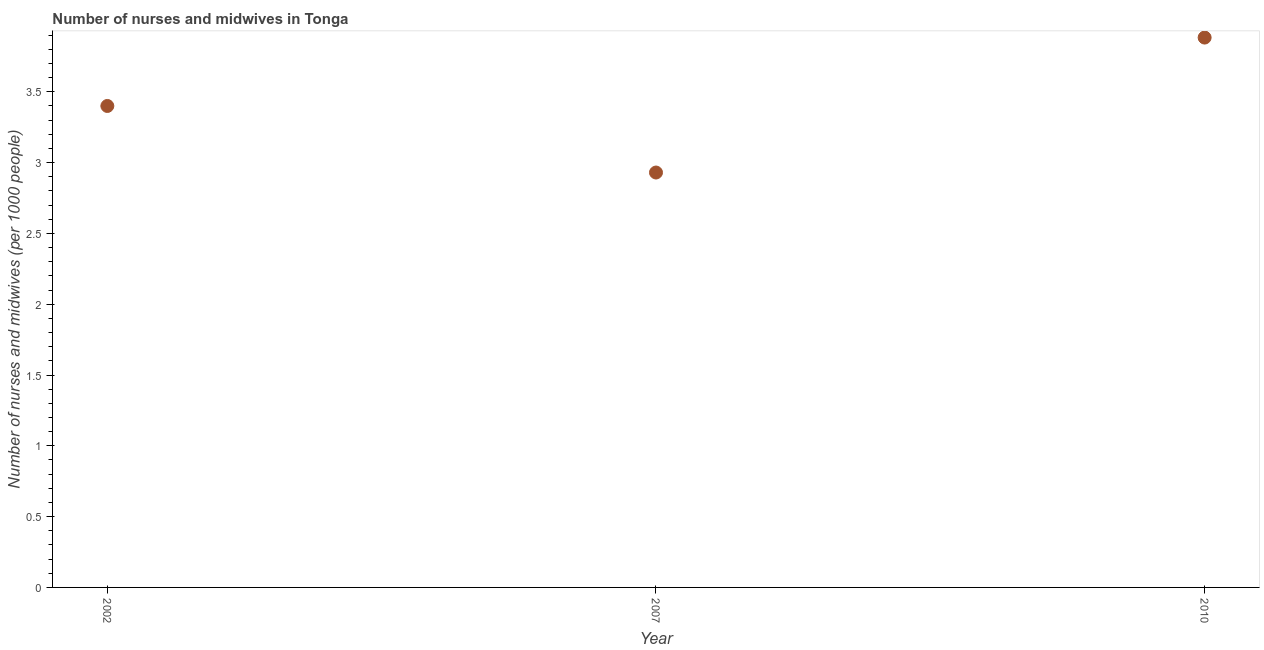What is the number of nurses and midwives in 2007?
Provide a succinct answer. 2.93. Across all years, what is the maximum number of nurses and midwives?
Offer a very short reply. 3.88. Across all years, what is the minimum number of nurses and midwives?
Provide a succinct answer. 2.93. In which year was the number of nurses and midwives minimum?
Give a very brief answer. 2007. What is the sum of the number of nurses and midwives?
Offer a terse response. 10.21. What is the difference between the number of nurses and midwives in 2002 and 2007?
Offer a terse response. 0.47. What is the average number of nurses and midwives per year?
Offer a very short reply. 3.4. In how many years, is the number of nurses and midwives greater than 1 ?
Your answer should be compact. 3. Do a majority of the years between 2002 and 2010 (inclusive) have number of nurses and midwives greater than 3.4 ?
Give a very brief answer. No. What is the ratio of the number of nurses and midwives in 2002 to that in 2007?
Give a very brief answer. 1.16. Is the difference between the number of nurses and midwives in 2007 and 2010 greater than the difference between any two years?
Offer a terse response. Yes. What is the difference between the highest and the second highest number of nurses and midwives?
Keep it short and to the point. 0.48. Is the sum of the number of nurses and midwives in 2002 and 2007 greater than the maximum number of nurses and midwives across all years?
Make the answer very short. Yes. What is the difference between the highest and the lowest number of nurses and midwives?
Offer a terse response. 0.95. Does the number of nurses and midwives monotonically increase over the years?
Give a very brief answer. No. How many years are there in the graph?
Offer a terse response. 3. What is the difference between two consecutive major ticks on the Y-axis?
Provide a succinct answer. 0.5. What is the title of the graph?
Make the answer very short. Number of nurses and midwives in Tonga. What is the label or title of the Y-axis?
Your answer should be compact. Number of nurses and midwives (per 1000 people). What is the Number of nurses and midwives (per 1000 people) in 2002?
Offer a very short reply. 3.4. What is the Number of nurses and midwives (per 1000 people) in 2007?
Keep it short and to the point. 2.93. What is the Number of nurses and midwives (per 1000 people) in 2010?
Offer a terse response. 3.88. What is the difference between the Number of nurses and midwives (per 1000 people) in 2002 and 2007?
Provide a short and direct response. 0.47. What is the difference between the Number of nurses and midwives (per 1000 people) in 2002 and 2010?
Ensure brevity in your answer.  -0.48. What is the difference between the Number of nurses and midwives (per 1000 people) in 2007 and 2010?
Your response must be concise. -0.95. What is the ratio of the Number of nurses and midwives (per 1000 people) in 2002 to that in 2007?
Give a very brief answer. 1.16. What is the ratio of the Number of nurses and midwives (per 1000 people) in 2002 to that in 2010?
Offer a very short reply. 0.88. What is the ratio of the Number of nurses and midwives (per 1000 people) in 2007 to that in 2010?
Your response must be concise. 0.76. 